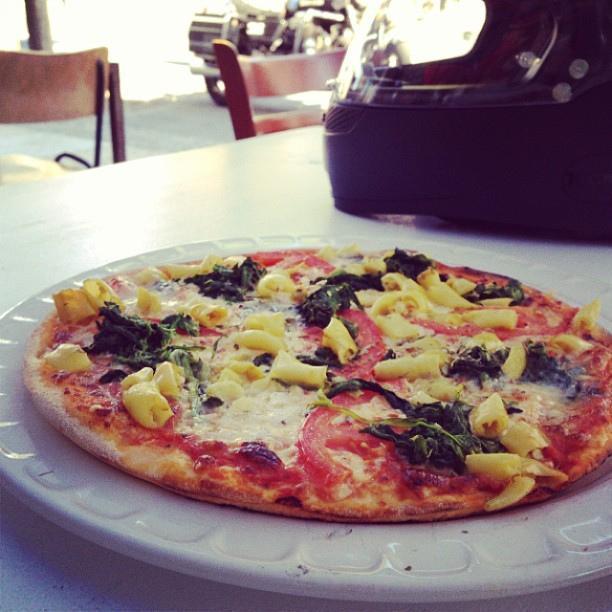How many pizzas are shown?
Give a very brief answer. 1. How many different foods are on the plate?
Give a very brief answer. 1. How many chairs can be seen?
Give a very brief answer. 2. How many motorcycles are there?
Give a very brief answer. 1. How many giraffes are in the photo?
Give a very brief answer. 0. 